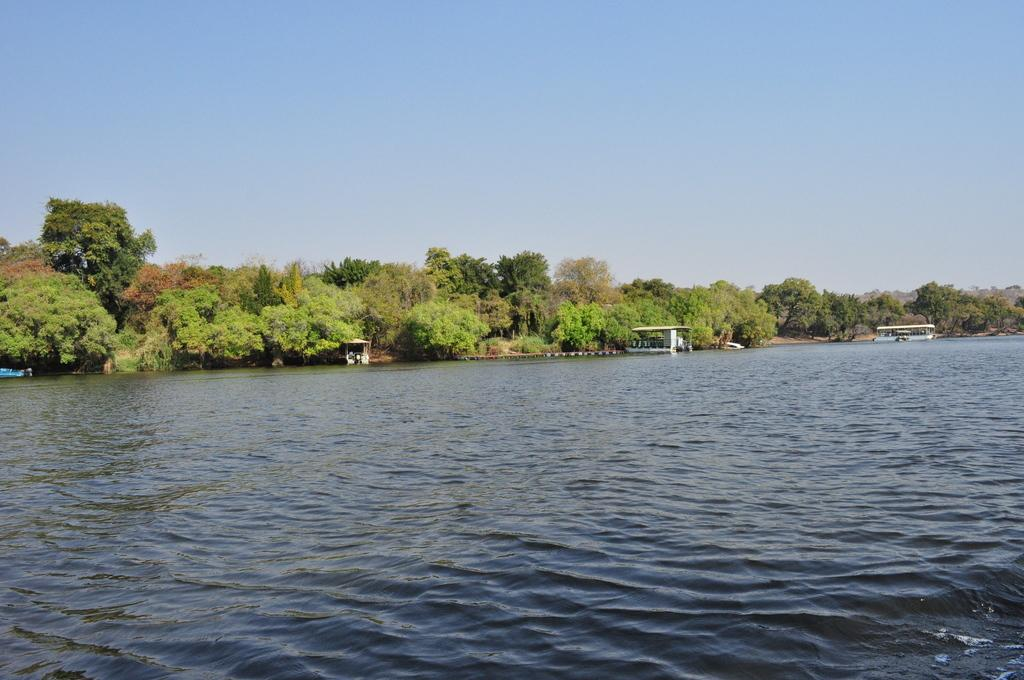What is visible in the image? Water is visible in the image. What can be seen in the background of the image? There are trees in the background of the image. What is present on the water in the image? There are boats on the water. How much money is being exchanged between the boats in the image? There is no indication of any money exchange between the boats in the image. What type of ray can be seen swimming in the water in the image? There is no ray present in the image; it only features water, trees, and boats. 